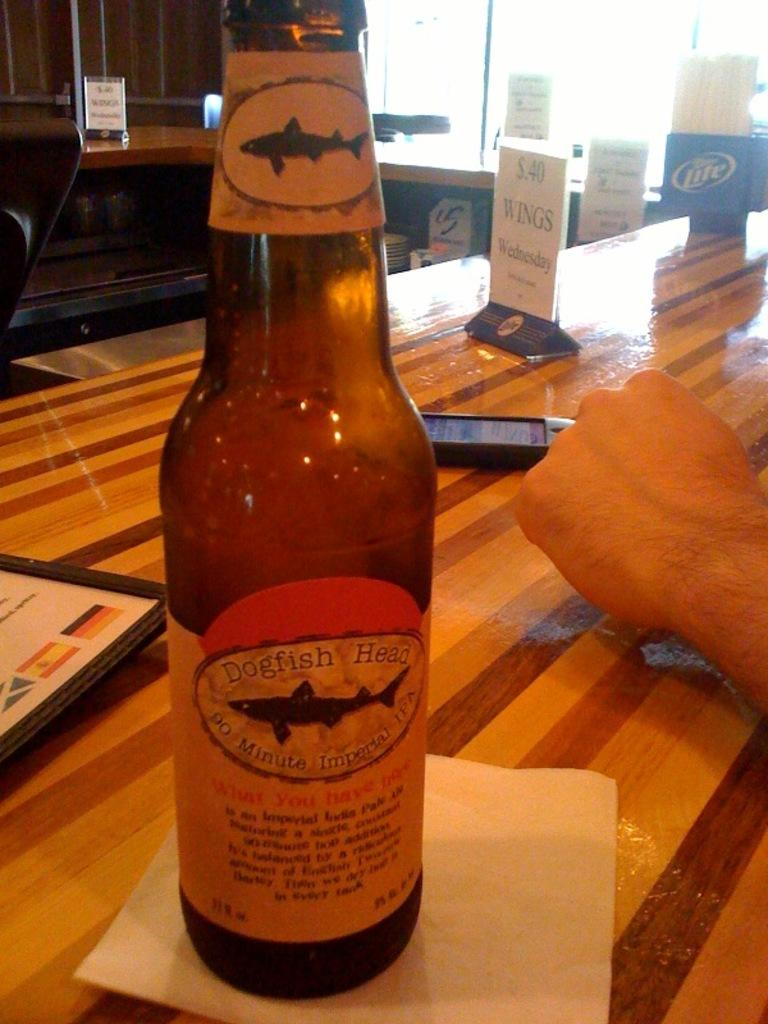<image>
Present a compact description of the photo's key features. A bottle of Dogfish Head IPA with a fish on the label. 